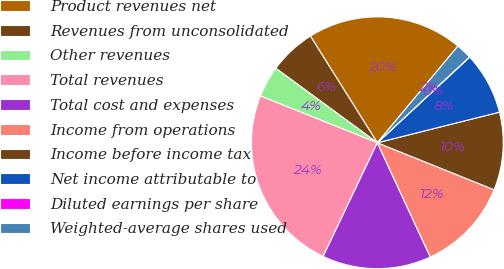Convert chart. <chart><loc_0><loc_0><loc_500><loc_500><pie_chart><fcel>Product revenues net<fcel>Revenues from unconsolidated<fcel>Other revenues<fcel>Total revenues<fcel>Total cost and expenses<fcel>Income from operations<fcel>Income before income tax<fcel>Net income attributable to<fcel>Diluted earnings per share<fcel>Weighted-average shares used<nl><fcel>19.98%<fcel>6.01%<fcel>4.01%<fcel>23.98%<fcel>13.99%<fcel>12.0%<fcel>10.0%<fcel>8.0%<fcel>0.02%<fcel>2.01%<nl></chart> 